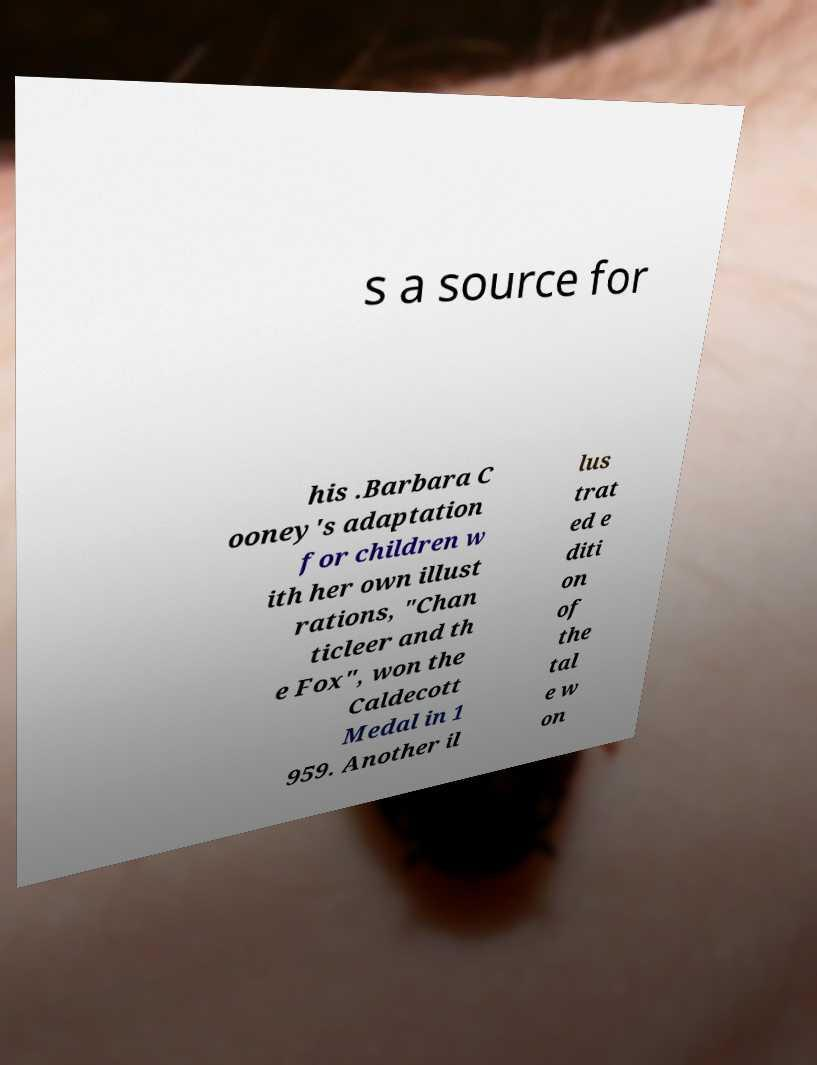Please read and relay the text visible in this image. What does it say? s a source for his .Barbara C ooney's adaptation for children w ith her own illust rations, "Chan ticleer and th e Fox", won the Caldecott Medal in 1 959. Another il lus trat ed e diti on of the tal e w on 